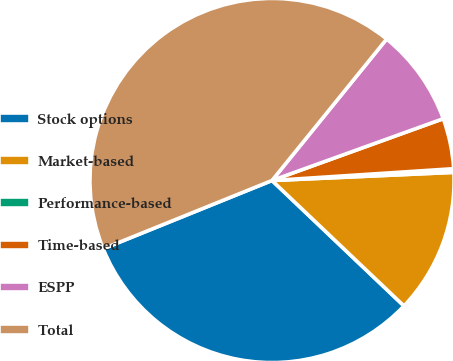<chart> <loc_0><loc_0><loc_500><loc_500><pie_chart><fcel>Stock options<fcel>Market-based<fcel>Performance-based<fcel>Time-based<fcel>ESPP<fcel>Total<nl><fcel>31.79%<fcel>12.81%<fcel>0.32%<fcel>4.48%<fcel>8.65%<fcel>41.96%<nl></chart> 